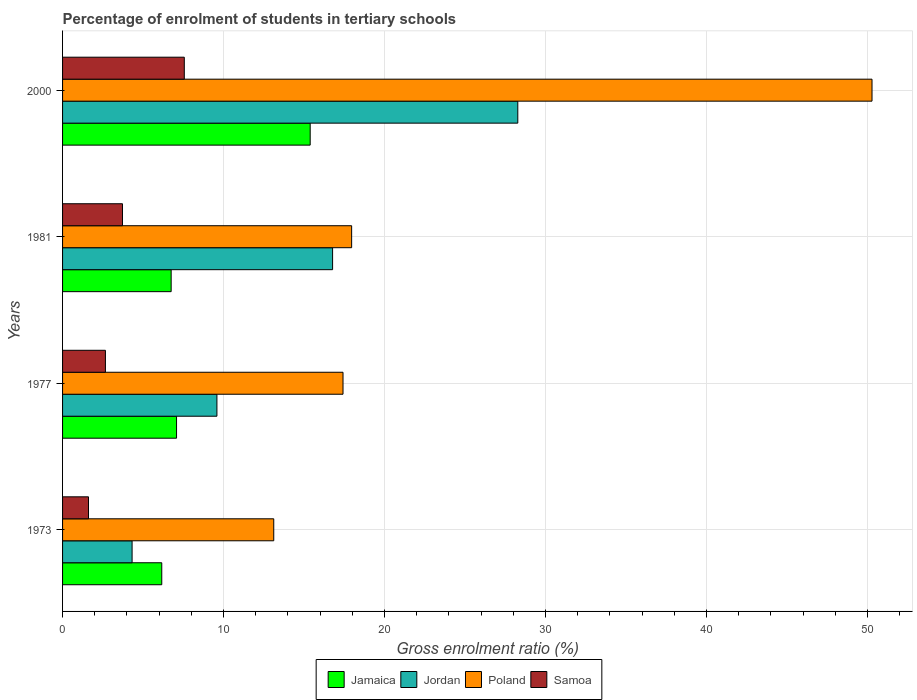How many groups of bars are there?
Offer a terse response. 4. Are the number of bars per tick equal to the number of legend labels?
Your response must be concise. Yes. In how many cases, is the number of bars for a given year not equal to the number of legend labels?
Keep it short and to the point. 0. What is the percentage of students enrolled in tertiary schools in Poland in 1977?
Ensure brevity in your answer.  17.42. Across all years, what is the maximum percentage of students enrolled in tertiary schools in Jamaica?
Your response must be concise. 15.38. Across all years, what is the minimum percentage of students enrolled in tertiary schools in Jordan?
Offer a very short reply. 4.32. What is the total percentage of students enrolled in tertiary schools in Samoa in the graph?
Offer a terse response. 15.56. What is the difference between the percentage of students enrolled in tertiary schools in Jordan in 1973 and that in 1981?
Provide a short and direct response. -12.46. What is the difference between the percentage of students enrolled in tertiary schools in Jordan in 1977 and the percentage of students enrolled in tertiary schools in Poland in 1973?
Provide a succinct answer. -3.53. What is the average percentage of students enrolled in tertiary schools in Poland per year?
Provide a succinct answer. 24.7. In the year 2000, what is the difference between the percentage of students enrolled in tertiary schools in Poland and percentage of students enrolled in tertiary schools in Jamaica?
Provide a succinct answer. 34.9. What is the ratio of the percentage of students enrolled in tertiary schools in Jordan in 1977 to that in 2000?
Offer a very short reply. 0.34. Is the percentage of students enrolled in tertiary schools in Samoa in 1977 less than that in 1981?
Provide a succinct answer. Yes. What is the difference between the highest and the second highest percentage of students enrolled in tertiary schools in Poland?
Your response must be concise. 32.33. What is the difference between the highest and the lowest percentage of students enrolled in tertiary schools in Poland?
Provide a short and direct response. 37.17. Is it the case that in every year, the sum of the percentage of students enrolled in tertiary schools in Poland and percentage of students enrolled in tertiary schools in Jordan is greater than the sum of percentage of students enrolled in tertiary schools in Jamaica and percentage of students enrolled in tertiary schools in Samoa?
Keep it short and to the point. No. What does the 3rd bar from the top in 1977 represents?
Provide a short and direct response. Jordan. Is it the case that in every year, the sum of the percentage of students enrolled in tertiary schools in Jordan and percentage of students enrolled in tertiary schools in Jamaica is greater than the percentage of students enrolled in tertiary schools in Samoa?
Offer a very short reply. Yes. How many bars are there?
Your answer should be very brief. 16. Are all the bars in the graph horizontal?
Your answer should be compact. Yes. What is the difference between two consecutive major ticks on the X-axis?
Make the answer very short. 10. Does the graph contain grids?
Give a very brief answer. Yes. How many legend labels are there?
Give a very brief answer. 4. What is the title of the graph?
Provide a succinct answer. Percentage of enrolment of students in tertiary schools. Does "Malta" appear as one of the legend labels in the graph?
Your answer should be very brief. No. What is the Gross enrolment ratio (%) of Jamaica in 1973?
Provide a succinct answer. 6.16. What is the Gross enrolment ratio (%) of Jordan in 1973?
Make the answer very short. 4.32. What is the Gross enrolment ratio (%) of Poland in 1973?
Give a very brief answer. 13.12. What is the Gross enrolment ratio (%) of Samoa in 1973?
Your answer should be very brief. 1.61. What is the Gross enrolment ratio (%) in Jamaica in 1977?
Keep it short and to the point. 7.08. What is the Gross enrolment ratio (%) of Jordan in 1977?
Offer a very short reply. 9.59. What is the Gross enrolment ratio (%) of Poland in 1977?
Offer a very short reply. 17.42. What is the Gross enrolment ratio (%) of Samoa in 1977?
Offer a very short reply. 2.66. What is the Gross enrolment ratio (%) in Jamaica in 1981?
Provide a short and direct response. 6.75. What is the Gross enrolment ratio (%) in Jordan in 1981?
Give a very brief answer. 16.78. What is the Gross enrolment ratio (%) in Poland in 1981?
Offer a terse response. 17.96. What is the Gross enrolment ratio (%) of Samoa in 1981?
Provide a short and direct response. 3.72. What is the Gross enrolment ratio (%) of Jamaica in 2000?
Your answer should be compact. 15.38. What is the Gross enrolment ratio (%) in Jordan in 2000?
Keep it short and to the point. 28.28. What is the Gross enrolment ratio (%) of Poland in 2000?
Your response must be concise. 50.29. What is the Gross enrolment ratio (%) in Samoa in 2000?
Keep it short and to the point. 7.56. Across all years, what is the maximum Gross enrolment ratio (%) in Jamaica?
Your response must be concise. 15.38. Across all years, what is the maximum Gross enrolment ratio (%) of Jordan?
Provide a short and direct response. 28.28. Across all years, what is the maximum Gross enrolment ratio (%) in Poland?
Keep it short and to the point. 50.29. Across all years, what is the maximum Gross enrolment ratio (%) of Samoa?
Your answer should be very brief. 7.56. Across all years, what is the minimum Gross enrolment ratio (%) of Jamaica?
Give a very brief answer. 6.16. Across all years, what is the minimum Gross enrolment ratio (%) of Jordan?
Your answer should be compact. 4.32. Across all years, what is the minimum Gross enrolment ratio (%) of Poland?
Provide a short and direct response. 13.12. Across all years, what is the minimum Gross enrolment ratio (%) of Samoa?
Provide a succinct answer. 1.61. What is the total Gross enrolment ratio (%) of Jamaica in the graph?
Provide a succinct answer. 35.37. What is the total Gross enrolment ratio (%) of Jordan in the graph?
Offer a terse response. 58.96. What is the total Gross enrolment ratio (%) in Poland in the graph?
Offer a terse response. 98.79. What is the total Gross enrolment ratio (%) in Samoa in the graph?
Offer a terse response. 15.56. What is the difference between the Gross enrolment ratio (%) of Jamaica in 1973 and that in 1977?
Offer a very short reply. -0.92. What is the difference between the Gross enrolment ratio (%) in Jordan in 1973 and that in 1977?
Provide a succinct answer. -5.27. What is the difference between the Gross enrolment ratio (%) in Poland in 1973 and that in 1977?
Give a very brief answer. -4.3. What is the difference between the Gross enrolment ratio (%) in Samoa in 1973 and that in 1977?
Your answer should be very brief. -1.05. What is the difference between the Gross enrolment ratio (%) in Jamaica in 1973 and that in 1981?
Keep it short and to the point. -0.58. What is the difference between the Gross enrolment ratio (%) in Jordan in 1973 and that in 1981?
Offer a very short reply. -12.46. What is the difference between the Gross enrolment ratio (%) in Poland in 1973 and that in 1981?
Keep it short and to the point. -4.84. What is the difference between the Gross enrolment ratio (%) in Samoa in 1973 and that in 1981?
Your answer should be compact. -2.11. What is the difference between the Gross enrolment ratio (%) in Jamaica in 1973 and that in 2000?
Make the answer very short. -9.22. What is the difference between the Gross enrolment ratio (%) in Jordan in 1973 and that in 2000?
Ensure brevity in your answer.  -23.96. What is the difference between the Gross enrolment ratio (%) in Poland in 1973 and that in 2000?
Keep it short and to the point. -37.17. What is the difference between the Gross enrolment ratio (%) of Samoa in 1973 and that in 2000?
Keep it short and to the point. -5.95. What is the difference between the Gross enrolment ratio (%) of Jamaica in 1977 and that in 1981?
Provide a short and direct response. 0.34. What is the difference between the Gross enrolment ratio (%) in Jordan in 1977 and that in 1981?
Offer a very short reply. -7.19. What is the difference between the Gross enrolment ratio (%) in Poland in 1977 and that in 1981?
Provide a short and direct response. -0.54. What is the difference between the Gross enrolment ratio (%) of Samoa in 1977 and that in 1981?
Make the answer very short. -1.06. What is the difference between the Gross enrolment ratio (%) of Jamaica in 1977 and that in 2000?
Offer a terse response. -8.3. What is the difference between the Gross enrolment ratio (%) of Jordan in 1977 and that in 2000?
Your answer should be compact. -18.69. What is the difference between the Gross enrolment ratio (%) in Poland in 1977 and that in 2000?
Provide a short and direct response. -32.86. What is the difference between the Gross enrolment ratio (%) of Samoa in 1977 and that in 2000?
Provide a succinct answer. -4.9. What is the difference between the Gross enrolment ratio (%) in Jamaica in 1981 and that in 2000?
Ensure brevity in your answer.  -8.64. What is the difference between the Gross enrolment ratio (%) of Jordan in 1981 and that in 2000?
Your response must be concise. -11.51. What is the difference between the Gross enrolment ratio (%) in Poland in 1981 and that in 2000?
Provide a short and direct response. -32.33. What is the difference between the Gross enrolment ratio (%) of Samoa in 1981 and that in 2000?
Make the answer very short. -3.84. What is the difference between the Gross enrolment ratio (%) of Jamaica in 1973 and the Gross enrolment ratio (%) of Jordan in 1977?
Offer a terse response. -3.43. What is the difference between the Gross enrolment ratio (%) of Jamaica in 1973 and the Gross enrolment ratio (%) of Poland in 1977?
Offer a very short reply. -11.26. What is the difference between the Gross enrolment ratio (%) in Jamaica in 1973 and the Gross enrolment ratio (%) in Samoa in 1977?
Your answer should be compact. 3.5. What is the difference between the Gross enrolment ratio (%) of Jordan in 1973 and the Gross enrolment ratio (%) of Poland in 1977?
Offer a very short reply. -13.1. What is the difference between the Gross enrolment ratio (%) in Jordan in 1973 and the Gross enrolment ratio (%) in Samoa in 1977?
Offer a very short reply. 1.66. What is the difference between the Gross enrolment ratio (%) in Poland in 1973 and the Gross enrolment ratio (%) in Samoa in 1977?
Provide a short and direct response. 10.46. What is the difference between the Gross enrolment ratio (%) of Jamaica in 1973 and the Gross enrolment ratio (%) of Jordan in 1981?
Give a very brief answer. -10.61. What is the difference between the Gross enrolment ratio (%) in Jamaica in 1973 and the Gross enrolment ratio (%) in Poland in 1981?
Offer a very short reply. -11.79. What is the difference between the Gross enrolment ratio (%) in Jamaica in 1973 and the Gross enrolment ratio (%) in Samoa in 1981?
Your answer should be very brief. 2.44. What is the difference between the Gross enrolment ratio (%) of Jordan in 1973 and the Gross enrolment ratio (%) of Poland in 1981?
Your answer should be compact. -13.64. What is the difference between the Gross enrolment ratio (%) in Jordan in 1973 and the Gross enrolment ratio (%) in Samoa in 1981?
Your answer should be very brief. 0.6. What is the difference between the Gross enrolment ratio (%) of Poland in 1973 and the Gross enrolment ratio (%) of Samoa in 1981?
Give a very brief answer. 9.4. What is the difference between the Gross enrolment ratio (%) of Jamaica in 1973 and the Gross enrolment ratio (%) of Jordan in 2000?
Give a very brief answer. -22.12. What is the difference between the Gross enrolment ratio (%) of Jamaica in 1973 and the Gross enrolment ratio (%) of Poland in 2000?
Ensure brevity in your answer.  -44.12. What is the difference between the Gross enrolment ratio (%) in Jamaica in 1973 and the Gross enrolment ratio (%) in Samoa in 2000?
Provide a succinct answer. -1.4. What is the difference between the Gross enrolment ratio (%) of Jordan in 1973 and the Gross enrolment ratio (%) of Poland in 2000?
Offer a terse response. -45.97. What is the difference between the Gross enrolment ratio (%) in Jordan in 1973 and the Gross enrolment ratio (%) in Samoa in 2000?
Keep it short and to the point. -3.24. What is the difference between the Gross enrolment ratio (%) in Poland in 1973 and the Gross enrolment ratio (%) in Samoa in 2000?
Keep it short and to the point. 5.56. What is the difference between the Gross enrolment ratio (%) of Jamaica in 1977 and the Gross enrolment ratio (%) of Jordan in 1981?
Your response must be concise. -9.69. What is the difference between the Gross enrolment ratio (%) in Jamaica in 1977 and the Gross enrolment ratio (%) in Poland in 1981?
Provide a short and direct response. -10.88. What is the difference between the Gross enrolment ratio (%) of Jamaica in 1977 and the Gross enrolment ratio (%) of Samoa in 1981?
Your answer should be very brief. 3.36. What is the difference between the Gross enrolment ratio (%) of Jordan in 1977 and the Gross enrolment ratio (%) of Poland in 1981?
Give a very brief answer. -8.37. What is the difference between the Gross enrolment ratio (%) of Jordan in 1977 and the Gross enrolment ratio (%) of Samoa in 1981?
Offer a very short reply. 5.87. What is the difference between the Gross enrolment ratio (%) in Poland in 1977 and the Gross enrolment ratio (%) in Samoa in 1981?
Offer a terse response. 13.7. What is the difference between the Gross enrolment ratio (%) of Jamaica in 1977 and the Gross enrolment ratio (%) of Jordan in 2000?
Offer a very short reply. -21.2. What is the difference between the Gross enrolment ratio (%) in Jamaica in 1977 and the Gross enrolment ratio (%) in Poland in 2000?
Your answer should be very brief. -43.21. What is the difference between the Gross enrolment ratio (%) in Jamaica in 1977 and the Gross enrolment ratio (%) in Samoa in 2000?
Offer a terse response. -0.48. What is the difference between the Gross enrolment ratio (%) in Jordan in 1977 and the Gross enrolment ratio (%) in Poland in 2000?
Offer a very short reply. -40.7. What is the difference between the Gross enrolment ratio (%) in Jordan in 1977 and the Gross enrolment ratio (%) in Samoa in 2000?
Make the answer very short. 2.03. What is the difference between the Gross enrolment ratio (%) of Poland in 1977 and the Gross enrolment ratio (%) of Samoa in 2000?
Make the answer very short. 9.86. What is the difference between the Gross enrolment ratio (%) in Jamaica in 1981 and the Gross enrolment ratio (%) in Jordan in 2000?
Your answer should be compact. -21.54. What is the difference between the Gross enrolment ratio (%) in Jamaica in 1981 and the Gross enrolment ratio (%) in Poland in 2000?
Offer a terse response. -43.54. What is the difference between the Gross enrolment ratio (%) in Jamaica in 1981 and the Gross enrolment ratio (%) in Samoa in 2000?
Offer a terse response. -0.82. What is the difference between the Gross enrolment ratio (%) of Jordan in 1981 and the Gross enrolment ratio (%) of Poland in 2000?
Give a very brief answer. -33.51. What is the difference between the Gross enrolment ratio (%) of Jordan in 1981 and the Gross enrolment ratio (%) of Samoa in 2000?
Keep it short and to the point. 9.21. What is the difference between the Gross enrolment ratio (%) in Poland in 1981 and the Gross enrolment ratio (%) in Samoa in 2000?
Make the answer very short. 10.4. What is the average Gross enrolment ratio (%) in Jamaica per year?
Provide a succinct answer. 8.84. What is the average Gross enrolment ratio (%) of Jordan per year?
Keep it short and to the point. 14.74. What is the average Gross enrolment ratio (%) in Poland per year?
Make the answer very short. 24.7. What is the average Gross enrolment ratio (%) in Samoa per year?
Your answer should be compact. 3.89. In the year 1973, what is the difference between the Gross enrolment ratio (%) of Jamaica and Gross enrolment ratio (%) of Jordan?
Provide a short and direct response. 1.84. In the year 1973, what is the difference between the Gross enrolment ratio (%) of Jamaica and Gross enrolment ratio (%) of Poland?
Provide a short and direct response. -6.96. In the year 1973, what is the difference between the Gross enrolment ratio (%) of Jamaica and Gross enrolment ratio (%) of Samoa?
Make the answer very short. 4.55. In the year 1973, what is the difference between the Gross enrolment ratio (%) in Jordan and Gross enrolment ratio (%) in Poland?
Make the answer very short. -8.8. In the year 1973, what is the difference between the Gross enrolment ratio (%) in Jordan and Gross enrolment ratio (%) in Samoa?
Your answer should be very brief. 2.71. In the year 1973, what is the difference between the Gross enrolment ratio (%) of Poland and Gross enrolment ratio (%) of Samoa?
Provide a succinct answer. 11.51. In the year 1977, what is the difference between the Gross enrolment ratio (%) in Jamaica and Gross enrolment ratio (%) in Jordan?
Keep it short and to the point. -2.51. In the year 1977, what is the difference between the Gross enrolment ratio (%) of Jamaica and Gross enrolment ratio (%) of Poland?
Give a very brief answer. -10.34. In the year 1977, what is the difference between the Gross enrolment ratio (%) of Jamaica and Gross enrolment ratio (%) of Samoa?
Your answer should be compact. 4.42. In the year 1977, what is the difference between the Gross enrolment ratio (%) in Jordan and Gross enrolment ratio (%) in Poland?
Offer a terse response. -7.83. In the year 1977, what is the difference between the Gross enrolment ratio (%) of Jordan and Gross enrolment ratio (%) of Samoa?
Give a very brief answer. 6.93. In the year 1977, what is the difference between the Gross enrolment ratio (%) in Poland and Gross enrolment ratio (%) in Samoa?
Offer a terse response. 14.76. In the year 1981, what is the difference between the Gross enrolment ratio (%) of Jamaica and Gross enrolment ratio (%) of Jordan?
Offer a terse response. -10.03. In the year 1981, what is the difference between the Gross enrolment ratio (%) in Jamaica and Gross enrolment ratio (%) in Poland?
Provide a short and direct response. -11.21. In the year 1981, what is the difference between the Gross enrolment ratio (%) of Jamaica and Gross enrolment ratio (%) of Samoa?
Offer a terse response. 3.02. In the year 1981, what is the difference between the Gross enrolment ratio (%) in Jordan and Gross enrolment ratio (%) in Poland?
Your response must be concise. -1.18. In the year 1981, what is the difference between the Gross enrolment ratio (%) in Jordan and Gross enrolment ratio (%) in Samoa?
Make the answer very short. 13.05. In the year 1981, what is the difference between the Gross enrolment ratio (%) of Poland and Gross enrolment ratio (%) of Samoa?
Offer a very short reply. 14.24. In the year 2000, what is the difference between the Gross enrolment ratio (%) in Jamaica and Gross enrolment ratio (%) in Jordan?
Make the answer very short. -12.9. In the year 2000, what is the difference between the Gross enrolment ratio (%) of Jamaica and Gross enrolment ratio (%) of Poland?
Ensure brevity in your answer.  -34.9. In the year 2000, what is the difference between the Gross enrolment ratio (%) in Jamaica and Gross enrolment ratio (%) in Samoa?
Offer a very short reply. 7.82. In the year 2000, what is the difference between the Gross enrolment ratio (%) of Jordan and Gross enrolment ratio (%) of Poland?
Your answer should be compact. -22.01. In the year 2000, what is the difference between the Gross enrolment ratio (%) in Jordan and Gross enrolment ratio (%) in Samoa?
Ensure brevity in your answer.  20.72. In the year 2000, what is the difference between the Gross enrolment ratio (%) in Poland and Gross enrolment ratio (%) in Samoa?
Provide a succinct answer. 42.72. What is the ratio of the Gross enrolment ratio (%) in Jamaica in 1973 to that in 1977?
Keep it short and to the point. 0.87. What is the ratio of the Gross enrolment ratio (%) in Jordan in 1973 to that in 1977?
Provide a succinct answer. 0.45. What is the ratio of the Gross enrolment ratio (%) of Poland in 1973 to that in 1977?
Offer a very short reply. 0.75. What is the ratio of the Gross enrolment ratio (%) of Samoa in 1973 to that in 1977?
Your response must be concise. 0.6. What is the ratio of the Gross enrolment ratio (%) of Jamaica in 1973 to that in 1981?
Ensure brevity in your answer.  0.91. What is the ratio of the Gross enrolment ratio (%) of Jordan in 1973 to that in 1981?
Provide a succinct answer. 0.26. What is the ratio of the Gross enrolment ratio (%) of Poland in 1973 to that in 1981?
Provide a succinct answer. 0.73. What is the ratio of the Gross enrolment ratio (%) of Samoa in 1973 to that in 1981?
Give a very brief answer. 0.43. What is the ratio of the Gross enrolment ratio (%) of Jamaica in 1973 to that in 2000?
Ensure brevity in your answer.  0.4. What is the ratio of the Gross enrolment ratio (%) in Jordan in 1973 to that in 2000?
Your response must be concise. 0.15. What is the ratio of the Gross enrolment ratio (%) of Poland in 1973 to that in 2000?
Make the answer very short. 0.26. What is the ratio of the Gross enrolment ratio (%) in Samoa in 1973 to that in 2000?
Provide a short and direct response. 0.21. What is the ratio of the Gross enrolment ratio (%) of Jamaica in 1977 to that in 1981?
Make the answer very short. 1.05. What is the ratio of the Gross enrolment ratio (%) in Jordan in 1977 to that in 1981?
Make the answer very short. 0.57. What is the ratio of the Gross enrolment ratio (%) of Poland in 1977 to that in 1981?
Your answer should be very brief. 0.97. What is the ratio of the Gross enrolment ratio (%) in Samoa in 1977 to that in 1981?
Your answer should be very brief. 0.72. What is the ratio of the Gross enrolment ratio (%) in Jamaica in 1977 to that in 2000?
Provide a short and direct response. 0.46. What is the ratio of the Gross enrolment ratio (%) of Jordan in 1977 to that in 2000?
Offer a very short reply. 0.34. What is the ratio of the Gross enrolment ratio (%) of Poland in 1977 to that in 2000?
Provide a succinct answer. 0.35. What is the ratio of the Gross enrolment ratio (%) of Samoa in 1977 to that in 2000?
Give a very brief answer. 0.35. What is the ratio of the Gross enrolment ratio (%) of Jamaica in 1981 to that in 2000?
Offer a terse response. 0.44. What is the ratio of the Gross enrolment ratio (%) of Jordan in 1981 to that in 2000?
Offer a very short reply. 0.59. What is the ratio of the Gross enrolment ratio (%) in Poland in 1981 to that in 2000?
Your answer should be compact. 0.36. What is the ratio of the Gross enrolment ratio (%) of Samoa in 1981 to that in 2000?
Provide a succinct answer. 0.49. What is the difference between the highest and the second highest Gross enrolment ratio (%) of Jamaica?
Make the answer very short. 8.3. What is the difference between the highest and the second highest Gross enrolment ratio (%) of Jordan?
Provide a succinct answer. 11.51. What is the difference between the highest and the second highest Gross enrolment ratio (%) of Poland?
Your answer should be very brief. 32.33. What is the difference between the highest and the second highest Gross enrolment ratio (%) of Samoa?
Your answer should be very brief. 3.84. What is the difference between the highest and the lowest Gross enrolment ratio (%) of Jamaica?
Your answer should be very brief. 9.22. What is the difference between the highest and the lowest Gross enrolment ratio (%) of Jordan?
Make the answer very short. 23.96. What is the difference between the highest and the lowest Gross enrolment ratio (%) in Poland?
Provide a short and direct response. 37.17. What is the difference between the highest and the lowest Gross enrolment ratio (%) in Samoa?
Make the answer very short. 5.95. 